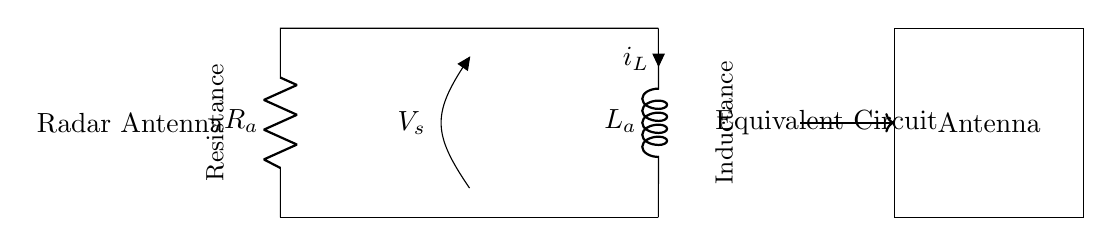What components are in the circuit? The circuit diagram contains a resistor and an inductor, as well as a voltage source. The resistor is labeled R_a and the inductor is labeled L_a.
Answer: Resistor and Inductor What does V_s represent in this circuit? V_s represents the voltage source connected across the parallel combination of the resistor and inductor. It indicates the voltage supplied to the RL circuit.
Answer: Voltage source What is the role of R_a in the circuit? R_a acts as a resistive element that limits the current flowing through the circuit and affects the overall impedance when combined with the inductor.
Answer: Current limiter What is the relationship between current and voltage in this parallel circuit? In a parallel RL circuit, the voltage across both the resistor and inductor is the same, but the currents through each component may differ based on their respective impedances.
Answer: Same voltage, different currents How does the impedance of the RL circuit affect radar operation? The impedance determines how the circuit responds to frequency changes, affecting the radar antenna's efficiency and resonance for optimal signal transmission.
Answer: Affects efficiency 